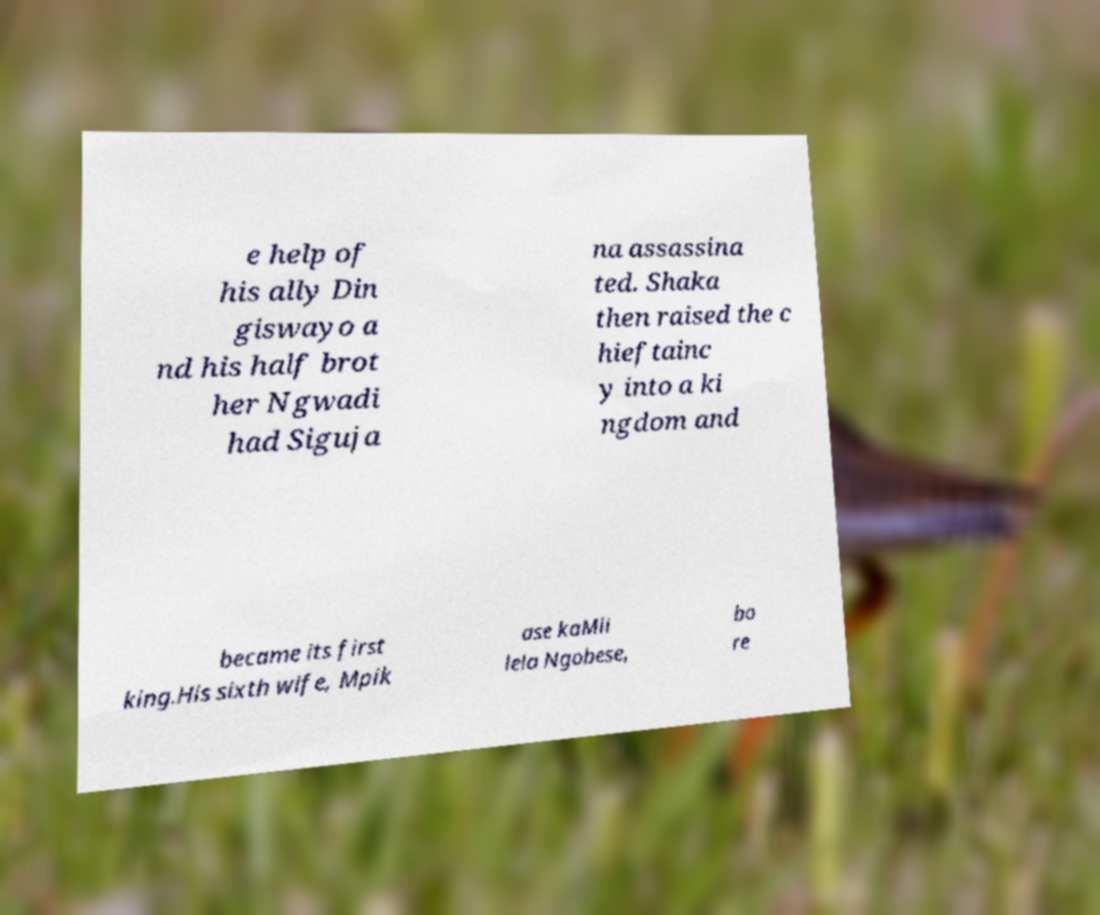Please read and relay the text visible in this image. What does it say? e help of his ally Din giswayo a nd his half brot her Ngwadi had Siguja na assassina ted. Shaka then raised the c hieftainc y into a ki ngdom and became its first king.His sixth wife, Mpik ase kaMli lela Ngobese, bo re 